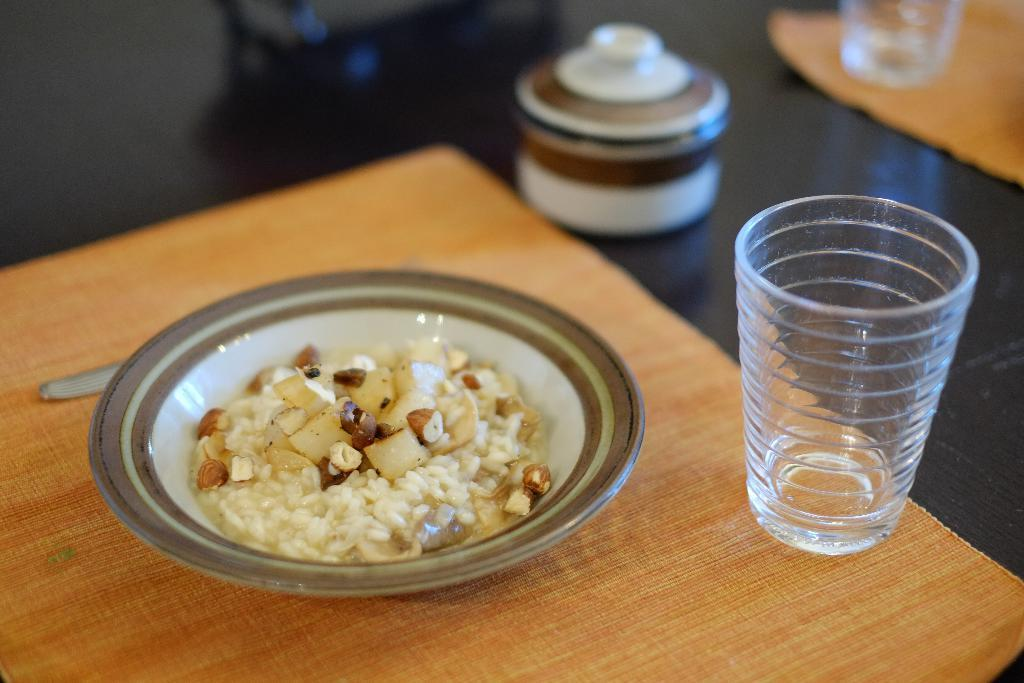What is the main piece of furniture in the image? There is a table in the image. What items are placed on the table? There are two cloths, glasses, a bowl, and a plate on the table. What is in the plate on the table? There is a food item in the plate, and there is a spoon in the plate as well. How would you describe the background of the image? The background of the image is blurred. How many legs does the nerve have in the image? There is no nerve present in the image, so it is not possible to determine how many legs it might have. 